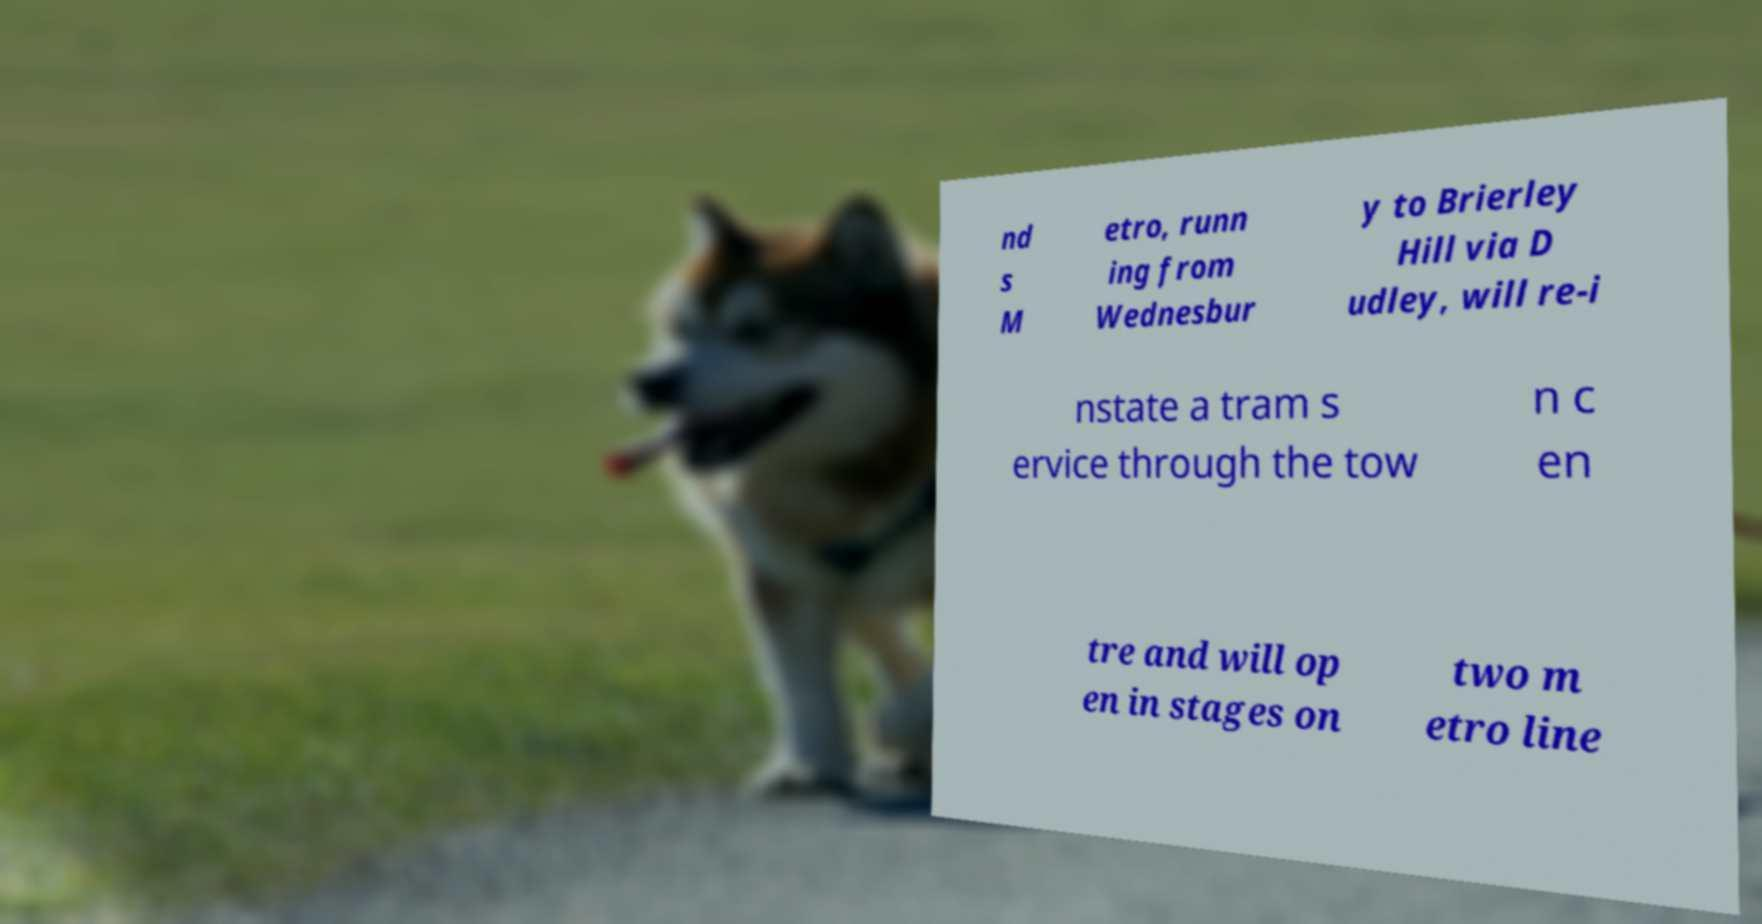Could you assist in decoding the text presented in this image and type it out clearly? nd s M etro, runn ing from Wednesbur y to Brierley Hill via D udley, will re-i nstate a tram s ervice through the tow n c en tre and will op en in stages on two m etro line 